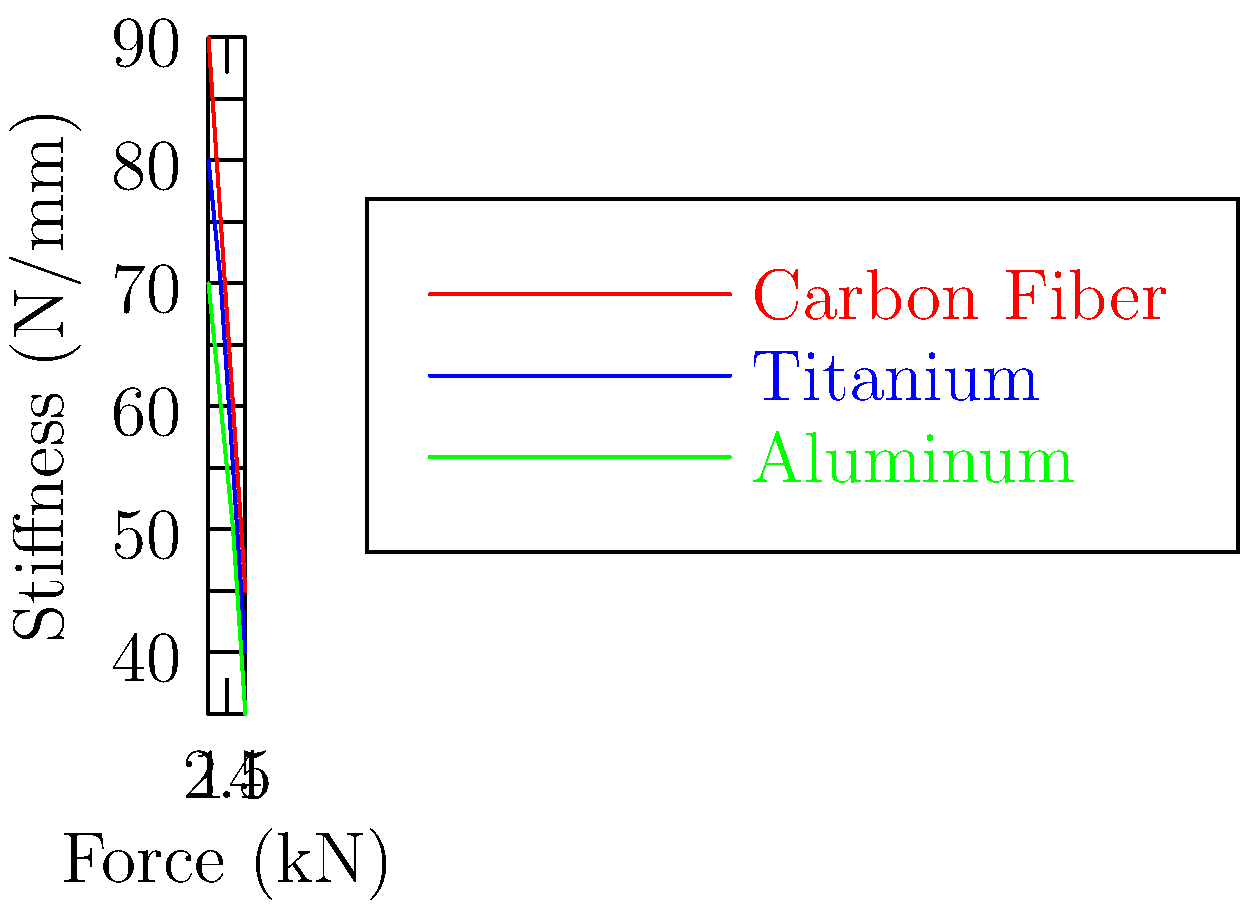Based on the comparison chart of mechanical properties for different prosthetic limb materials, which material exhibits the highest stiffness under increasing force, and how might this impact health policy decisions regarding prosthetic prescriptions? To answer this question, we need to analyze the graph and consider its implications for health policy:

1. Interpret the graph:
   - The x-axis represents force in kilonewtons (kN)
   - The y-axis represents stiffness in newtons per millimeter (N/mm)
   - Three materials are compared: Carbon Fiber (red), Titanium (blue), and Aluminum (green)

2. Analyze the stiffness trends:
   - Carbon Fiber maintains the highest stiffness across all force levels
   - Titanium is the second stiffest material
   - Aluminum shows the lowest stiffness among the three

3. Calculate the rate of stiffness decrease:
   - Carbon Fiber: (90 - 45) / (4 - 1) = 15 N/mm per kN
   - Titanium: (80 - 40) / (4 - 1) = 13.33 N/mm per kN
   - Aluminum: (70 - 35) / (4 - 1) = 11.67 N/mm per kN

4. Consider health policy implications:
   - Higher stiffness generally means better energy return and responsiveness
   - Carbon Fiber prosthetics may offer better performance for active users
   - However, they may be more expensive and less durable than metal alternatives

5. Policy considerations:
   - Cost-effectiveness analysis of different materials
   - Patient needs assessment (e.g., activity level, weight)
   - Long-term durability and maintenance requirements
   - Manufacturing and supply chain considerations

6. Potential policy recommendations:
   - Tiered prescription system based on patient needs and activity levels
   - Research funding for improving the properties of more affordable materials
   - Standardized testing and quality control measures for prosthetic materials
Answer: Carbon Fiber; impacts include performance benefits for active users, higher costs, and the need for a tiered prescription system based on patient needs and activity levels. 